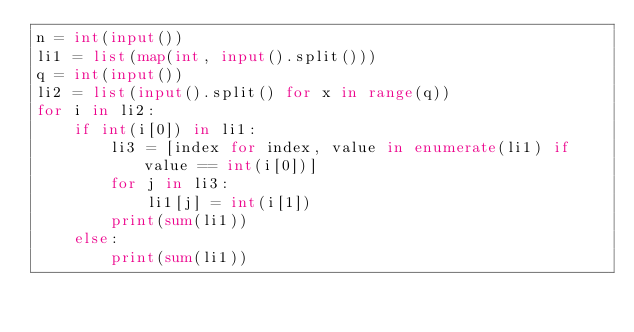Convert code to text. <code><loc_0><loc_0><loc_500><loc_500><_Python_>n = int(input())
li1 = list(map(int, input().split()))
q = int(input())
li2 = list(input().split() for x in range(q))
for i in li2:
    if int(i[0]) in li1:
        li3 = [index for index, value in enumerate(li1) if value == int(i[0])]
        for j in li3:
            li1[j] = int(i[1])
        print(sum(li1))
    else:
        print(sum(li1))
</code> 